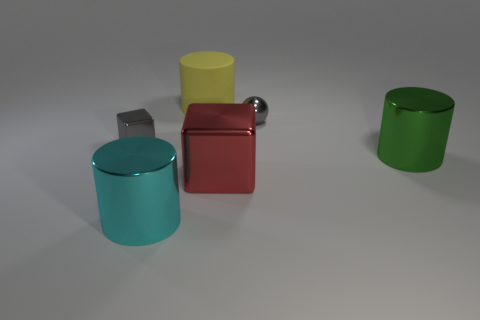Is there anything else that has the same material as the yellow thing?
Make the answer very short. No. There is a thing that is both to the left of the yellow object and on the right side of the small block; how big is it?
Offer a very short reply. Large. The large shiny object on the left side of the red shiny thing has what shape?
Provide a short and direct response. Cylinder. Is the material of the small ball the same as the cylinder on the left side of the large yellow rubber cylinder?
Your answer should be compact. Yes. Do the green thing and the large yellow thing have the same shape?
Give a very brief answer. Yes. What material is the yellow thing that is the same shape as the cyan object?
Make the answer very short. Rubber. What color is the thing that is both behind the tiny cube and to the right of the large yellow cylinder?
Ensure brevity in your answer.  Gray. What color is the sphere?
Your answer should be very brief. Gray. Is there another big thing that has the same shape as the big cyan object?
Provide a succinct answer. Yes. There is a metallic block to the right of the big yellow thing; what is its size?
Offer a very short reply. Large. 